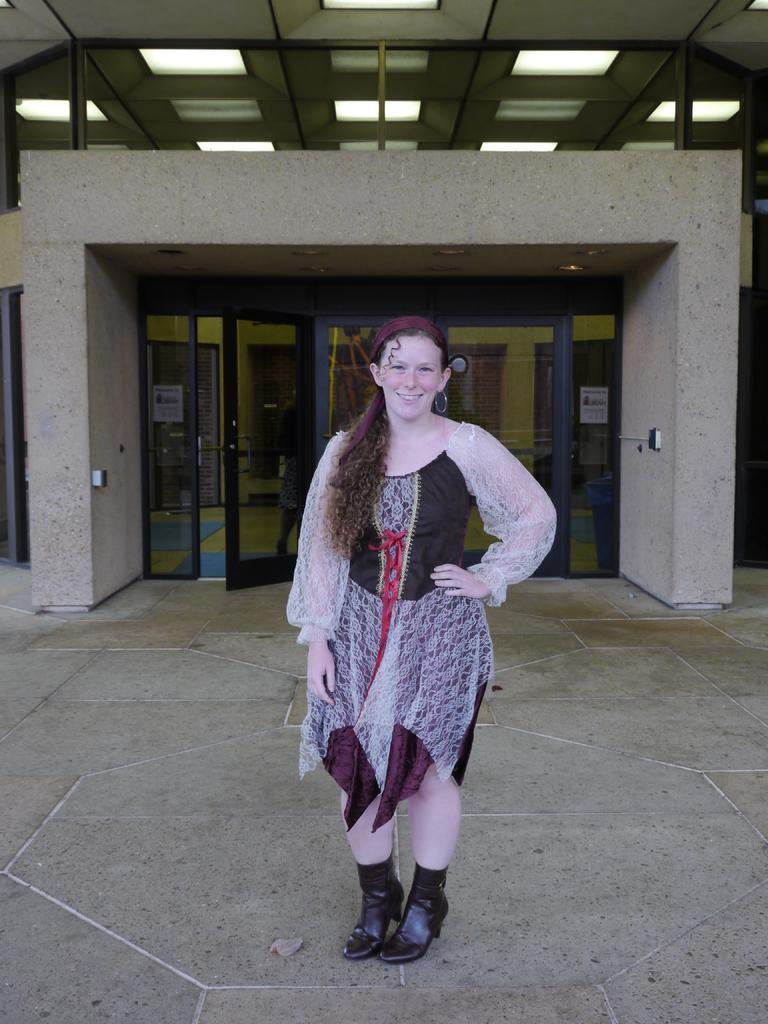What is the main subject of the image? There is a woman standing in the image. Where is the woman standing in relation to the path? The woman is standing in front of a path. What can be seen in the background of the image? There is a building in the background of the image. What is visible at the top of the image? Lights are visible at the top of the image. What type of books can be seen in the woman's hands in the image? There are no books visible in the image; the woman is not holding anything in her hands. 